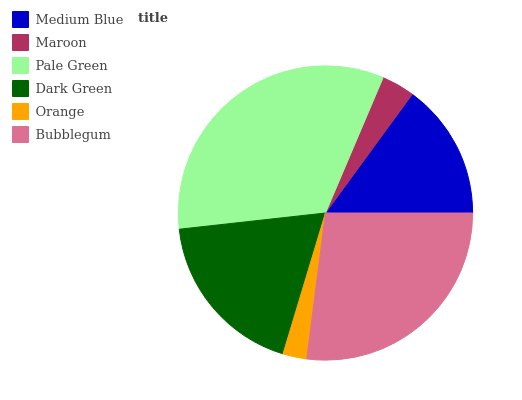Is Orange the minimum?
Answer yes or no. Yes. Is Pale Green the maximum?
Answer yes or no. Yes. Is Maroon the minimum?
Answer yes or no. No. Is Maroon the maximum?
Answer yes or no. No. Is Medium Blue greater than Maroon?
Answer yes or no. Yes. Is Maroon less than Medium Blue?
Answer yes or no. Yes. Is Maroon greater than Medium Blue?
Answer yes or no. No. Is Medium Blue less than Maroon?
Answer yes or no. No. Is Dark Green the high median?
Answer yes or no. Yes. Is Medium Blue the low median?
Answer yes or no. Yes. Is Medium Blue the high median?
Answer yes or no. No. Is Pale Green the low median?
Answer yes or no. No. 